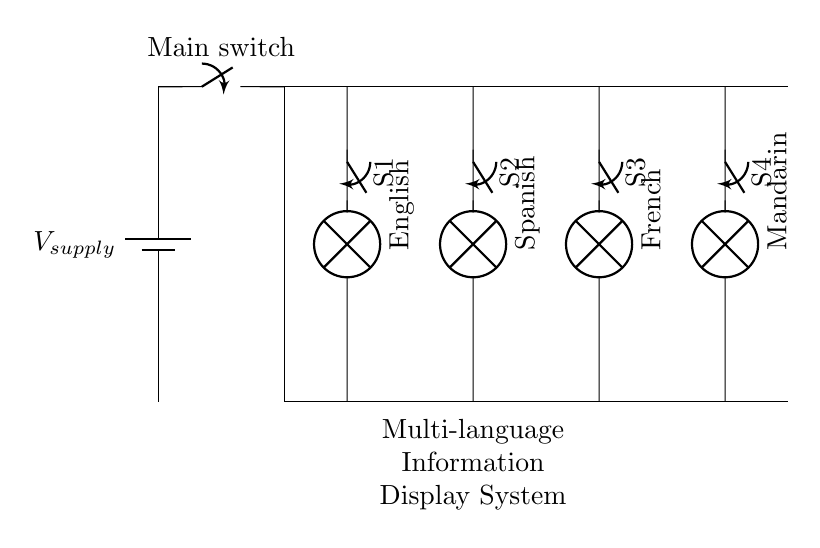What is the total number of display modules? There are four display modules in the circuit, labeled English, Spanish, French, and Mandarin. This can be identified by counting the number of lamps depicted in the circuit diagram.
Answer: four What does each lamp represent? Each lamp corresponds to a different language, specifically English, Spanish, French, and Mandarin. This is indicated by the labels attached to each lamp in the diagram.
Answer: languages How is the power supplied to the circuit? The power is supplied by a battery, shown on the left side of the circuit labeled as "V supply." This indicates that the entire circuit receives power from this single source.
Answer: battery What type of circuit configuration is used here? The circuit configuration used is a parallel circuit, where multiple branches operate independently from each other, allowing each language display to function independently when switched on.
Answer: parallel What is the purpose of the individual switches S1 to S4? The individual switches S1, S2, S3, and S4 allow control over the operation of each respective language display, meaning that each language can be turned on or off independently.
Answer: control What happens if one lamp fails? If one lamp fails, the other lamps will still function normally because they are in a parallel configuration. This can be deduced from the nature of parallel circuits; each branch operates independently.
Answer: unaffected How can the system be described overall? The system can be described as a multi-language information display system, as indicated by the label beneath the circuit diagram, designed to show information in various languages simultaneously.
Answer: multi-language information display system 